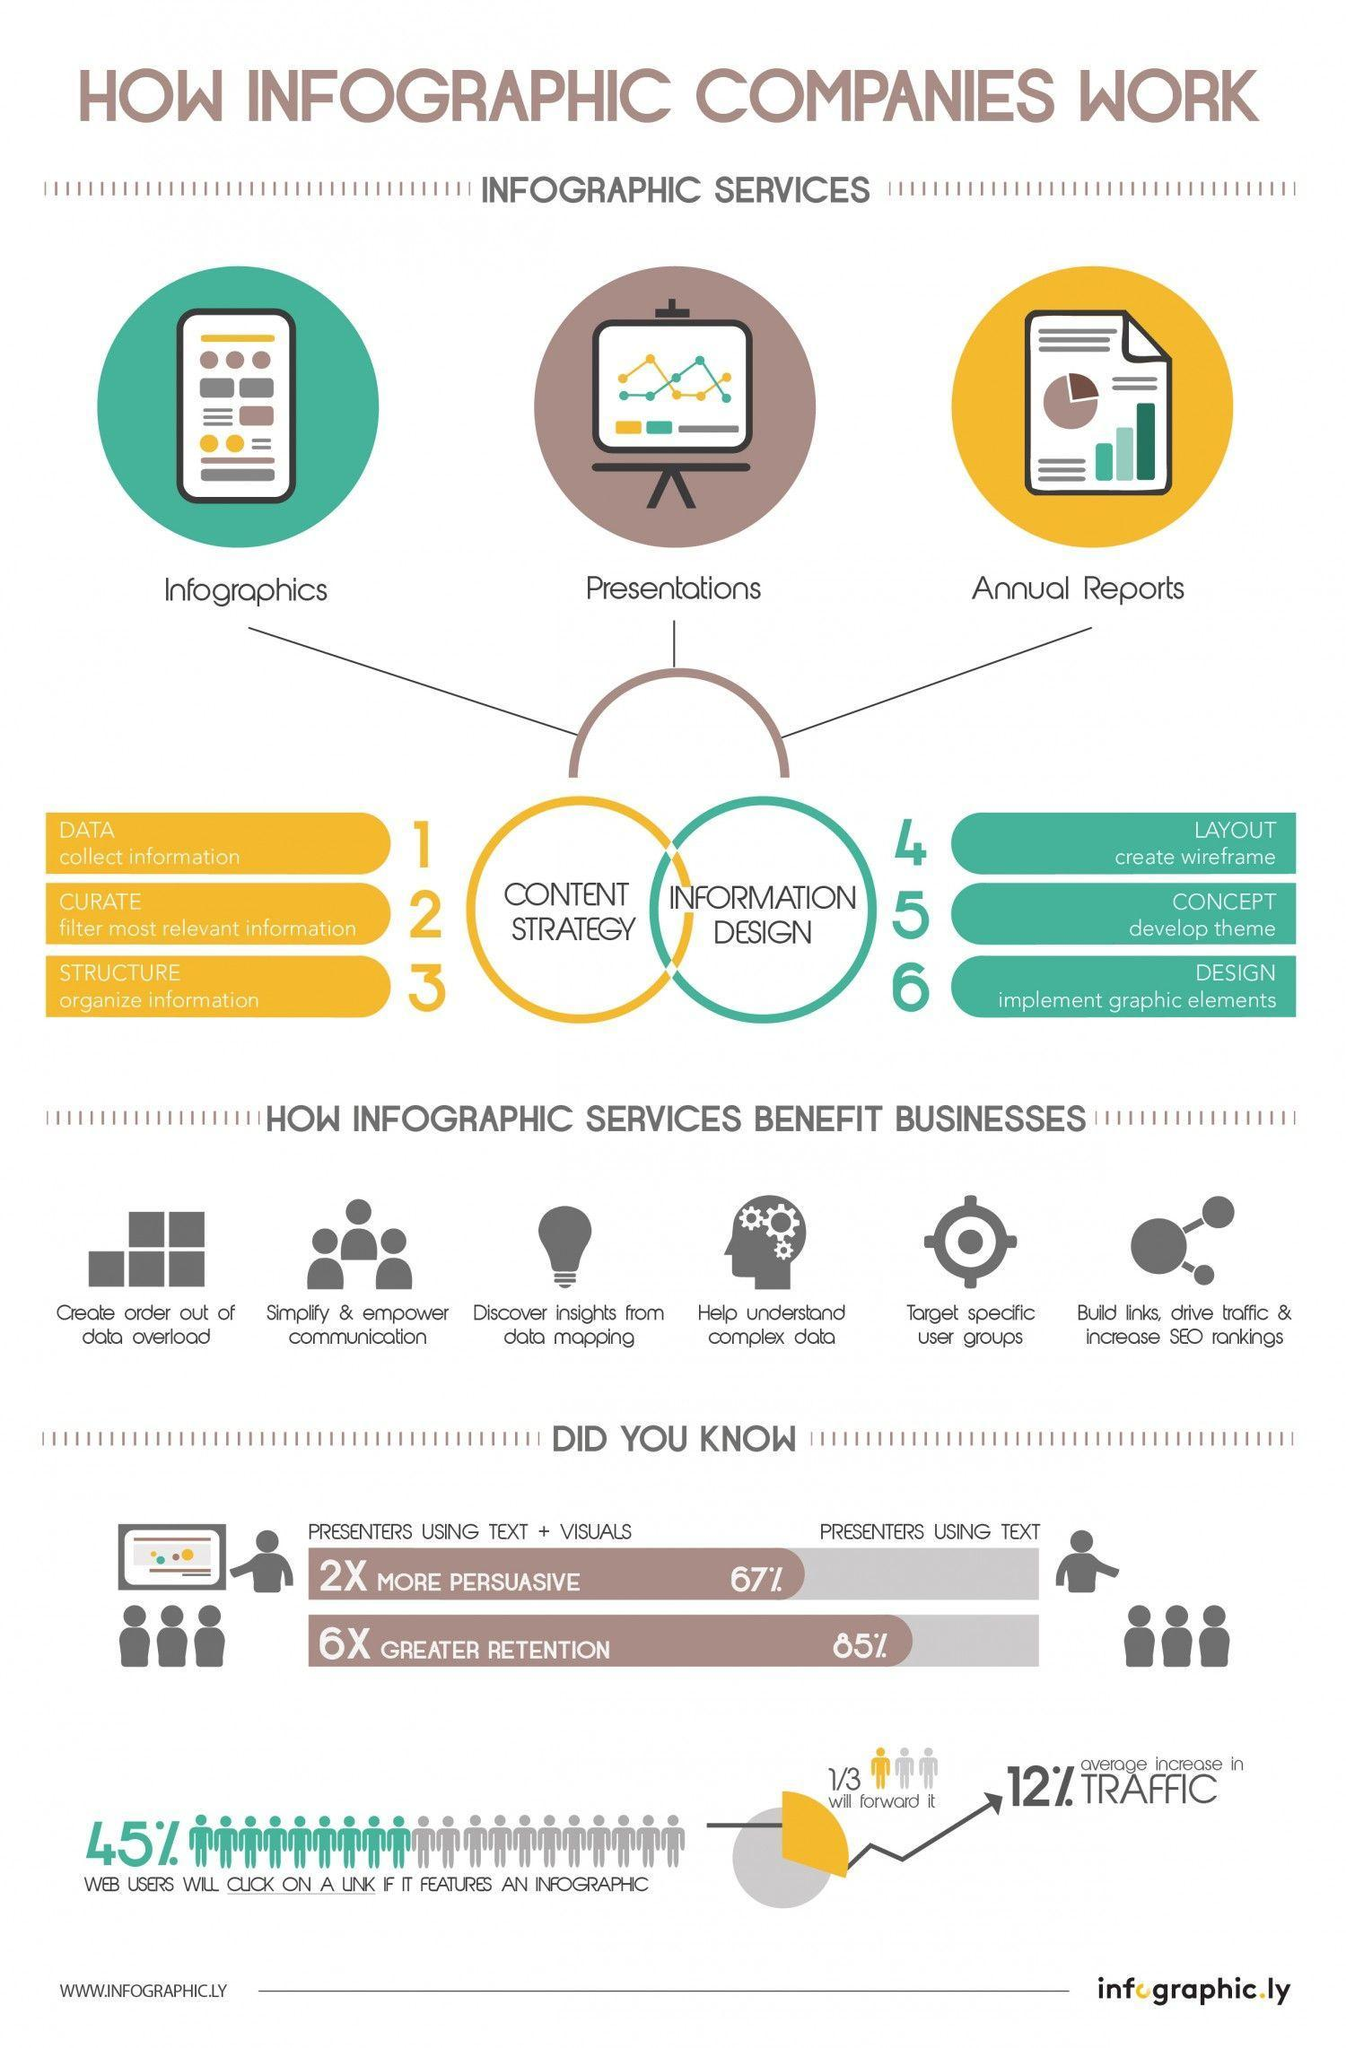what percent of people present data using text only?
Answer the question with a short phrase. 33% what are the three components of information design? layout, concept, design 